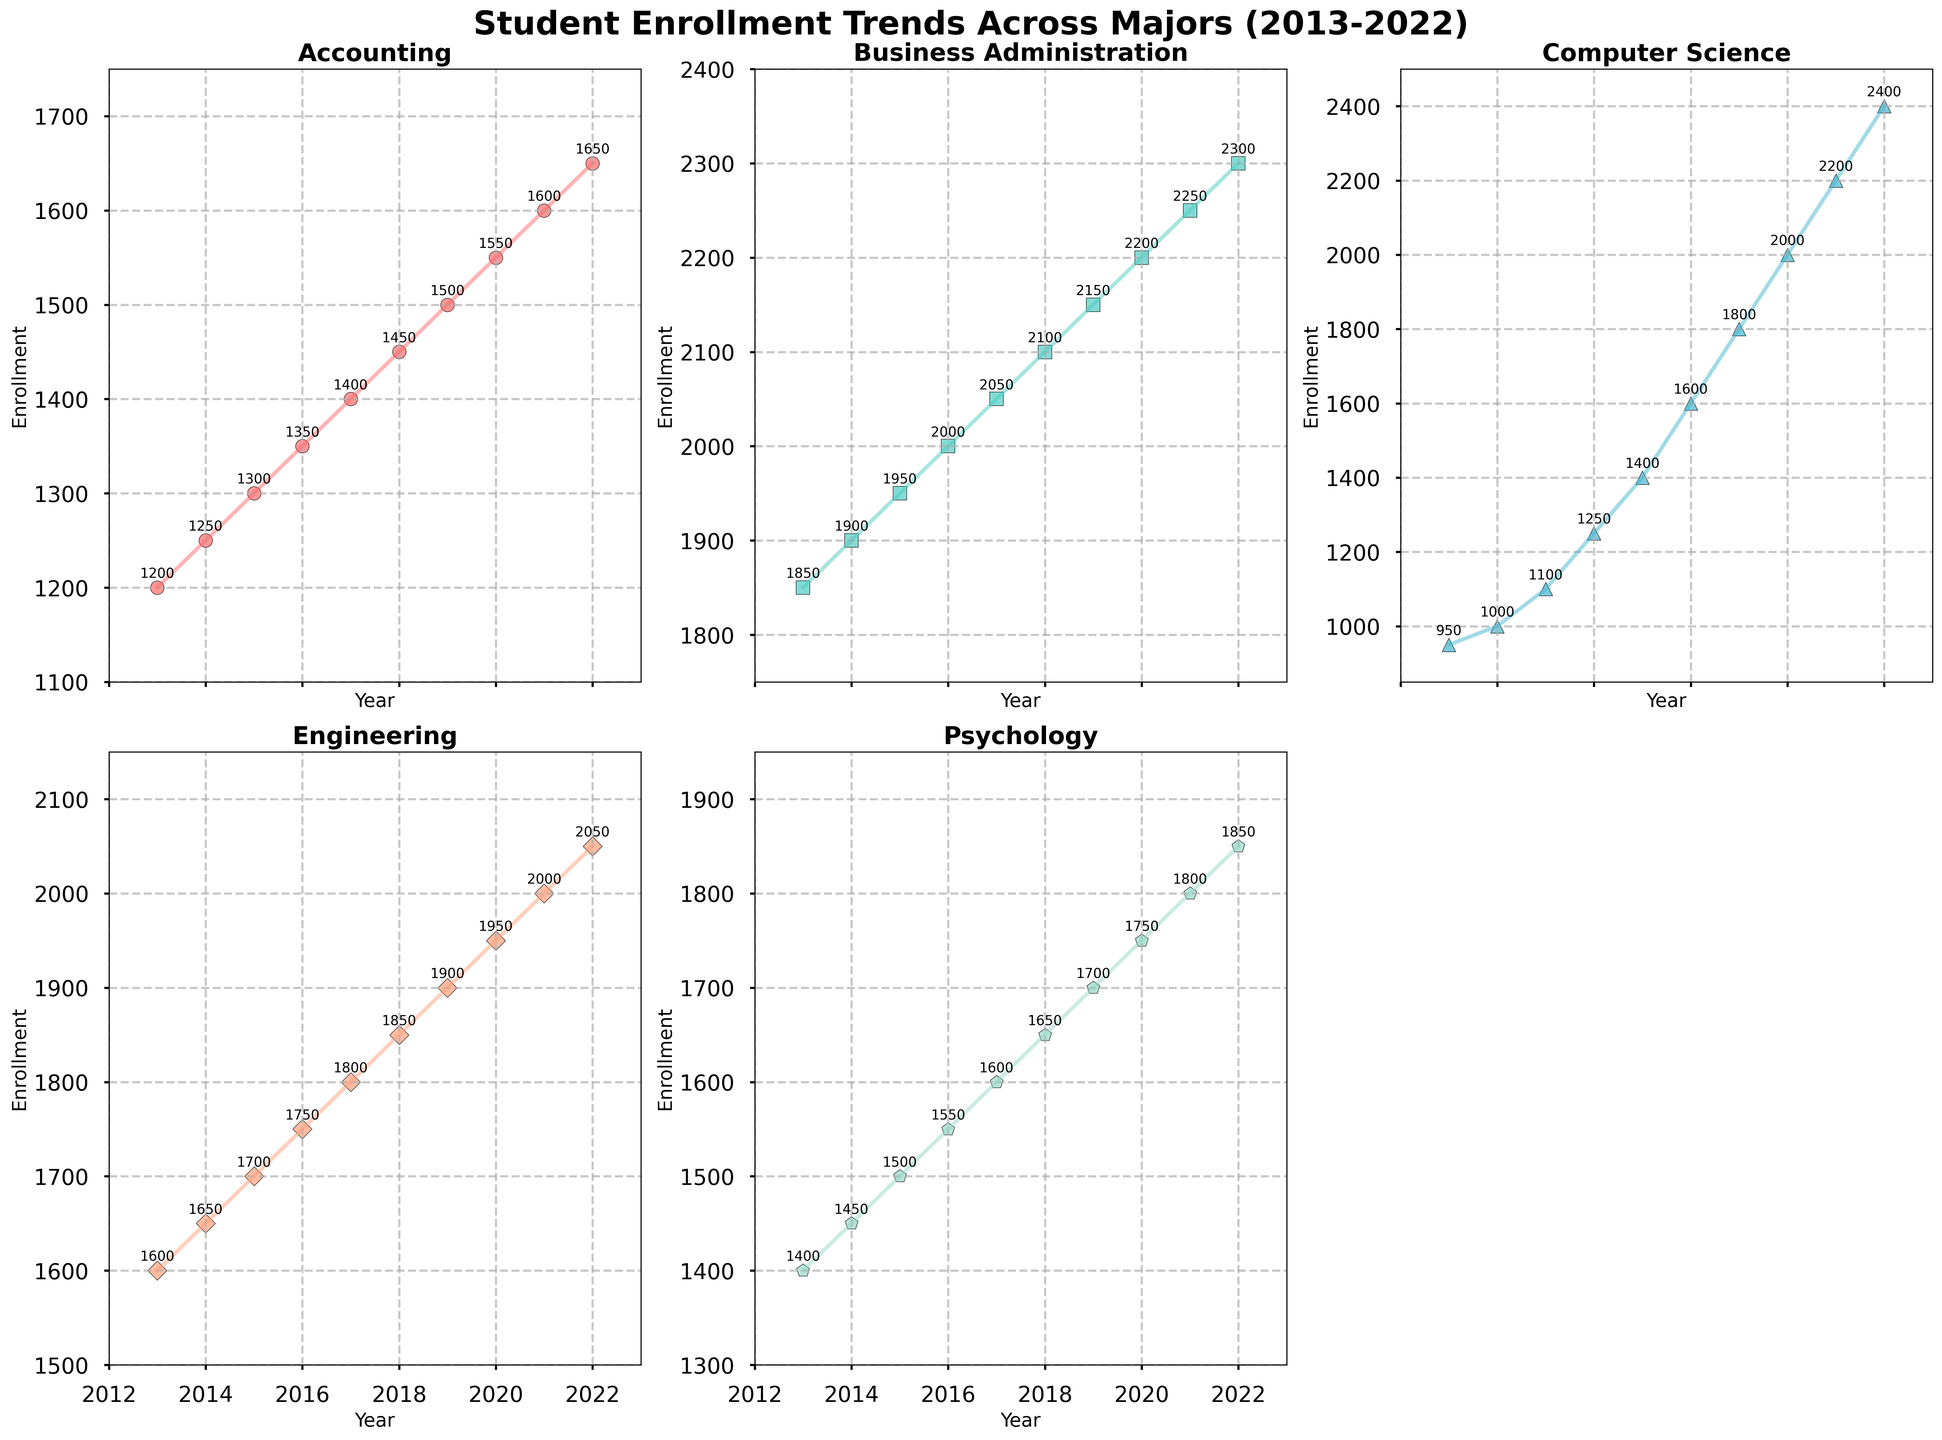Which major had the highest enrollment in 2022? According to the last data point for each major, Computer Science had the highest enrollment in 2022 with 2400 students.
Answer: Computer Science What is the overall trend observed in enrollment for Psychology over the decade? Visual inspection of the Psychology subplot shows an increasing trend from 1400 in 2013 to 1850 in 2022. Each subsequent year generally shows an increase in enrollment.
Answer: Increasing Compare the enrollment in Accounting and Engineering in 2016. Which one had more students enrolled? Looking at the 2016 data points for both Accounting and Engineering, Accounting has an enrollment of 1350 while Engineering has 1750, indicating Engineering has more students enrolled in that year.
Answer: Engineering What is the average enrollment for Business Administration over the decade? Sum the yearly enrollments for Business Administration from 2013 to 2022: 1850, 1900, 1950, 2000, 2050, 2100, 2150, 2200, 2250, 2300. The total sum is 20750. With 10 years of data, the average enrollment is 20750/10.
Answer: 2075 By how much did Computer Science enrollment increase from 2018 to 2022? From the subplot for Computer Science, enrollment in 2018 was 1600, and in 2022 it was 2400. The increase is calculated as 2400 - 1600.
Answer: 800 In which year did Engineering enrollment first surpass 2000? Refer to the Engineering subplot and observe the data points. Enrollment surpasses 2000 in 2021, with an enrollment of 2000.
Answer: 2021 If we consider the rate of increase, which major experienced the fastest growth over the decade? Examine each subplot by visually comparing the slopes of the plotted lines. Computer Science shows the steepest slope, growing from 950 in 2013 to 2400 in 2022.
Answer: Computer Science What is the approximate difference in enrollment between the most and least popular majors in 2020? The most popular major in 2020 is Business Administration with 2200 enrollments and the least popular is Psychology with 1750 enrollments. The difference is 2200 - 1750.
Answer: 450 Identify the trend and describe the visual patterns for Accounting from 2013 to 2022. Observe the scatter plot and line for Accounting. The data shows a consistent upward trend, with each year recording a higher enrollment figure compared to the previous year.
Answer: Consistent upward trend Which major had the least enrollment in the first year, 2013, and what was the number? In 2013, Computer Science had the least enrollment with 950 students, as shown on its respective subplot.
Answer: Computer Science, 950 